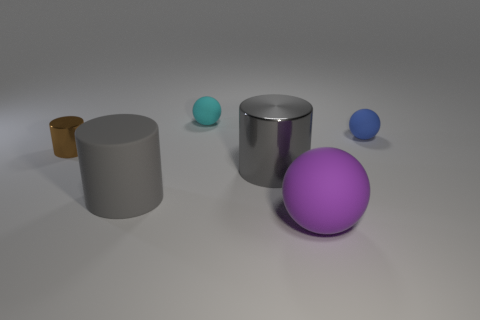Subtract all small spheres. How many spheres are left? 1 Add 2 cylinders. How many objects exist? 8 Subtract all brown blocks. How many gray cylinders are left? 2 Subtract 1 balls. How many balls are left? 2 Subtract all brown cylinders. How many cylinders are left? 2 Subtract all green cylinders. Subtract all blue cubes. How many cylinders are left? 3 Add 4 cyan spheres. How many cyan spheres exist? 5 Subtract 1 blue balls. How many objects are left? 5 Subtract all green objects. Subtract all large cylinders. How many objects are left? 4 Add 2 big gray cylinders. How many big gray cylinders are left? 4 